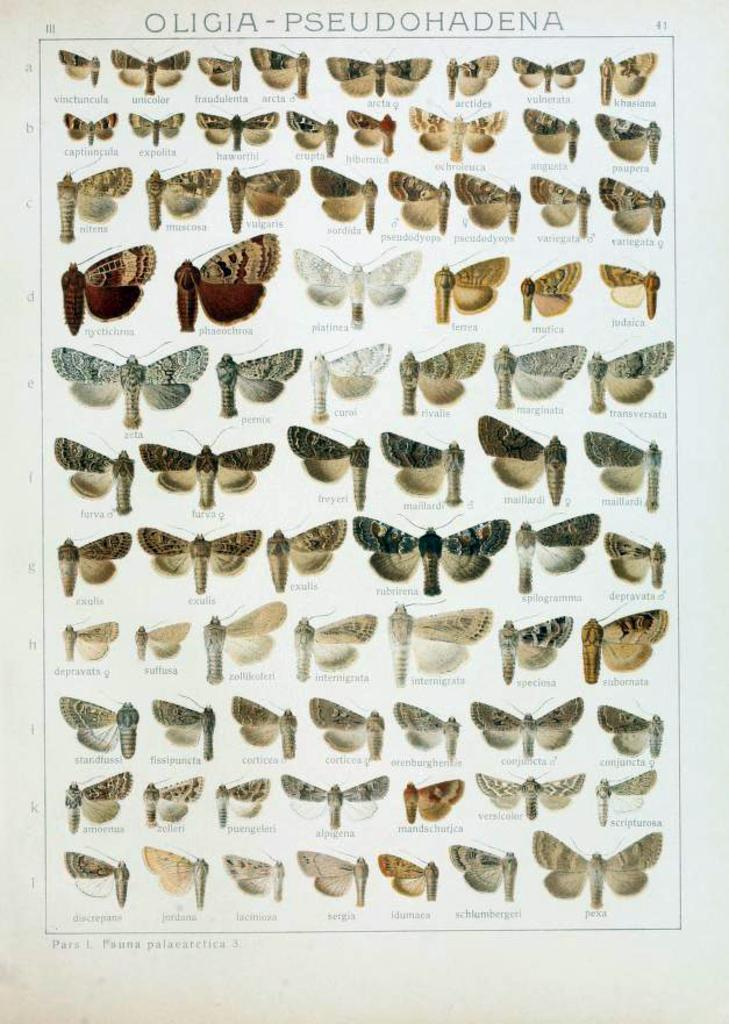What is the main subject of the group of photos in the image? The photos depict butterflies. What else can be seen in the image besides the photos? There is text present on the image. How many quarters are visible in the image? There are no quarters present in the image. What type of cast is featured in the image? There is no cast present in the image. 